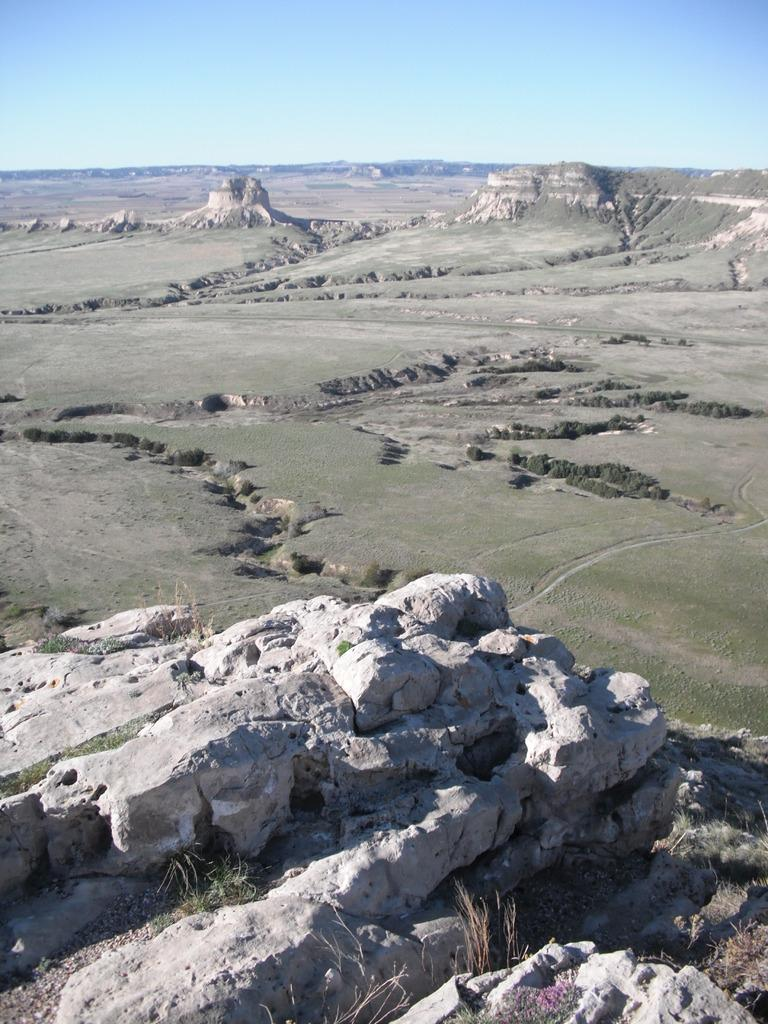What type of natural landform can be seen in the image? There are mountains in the image. What type of vegetation is visible in the image? There is grass visible in the image. What part of the natural environment is visible in the background of the image? The sky is visible in the background of the image. What type of stone is being used to help build the mountains in the image? There is no indication of any stone or construction activity in the image; it simply shows mountains, grass, and the sky. 